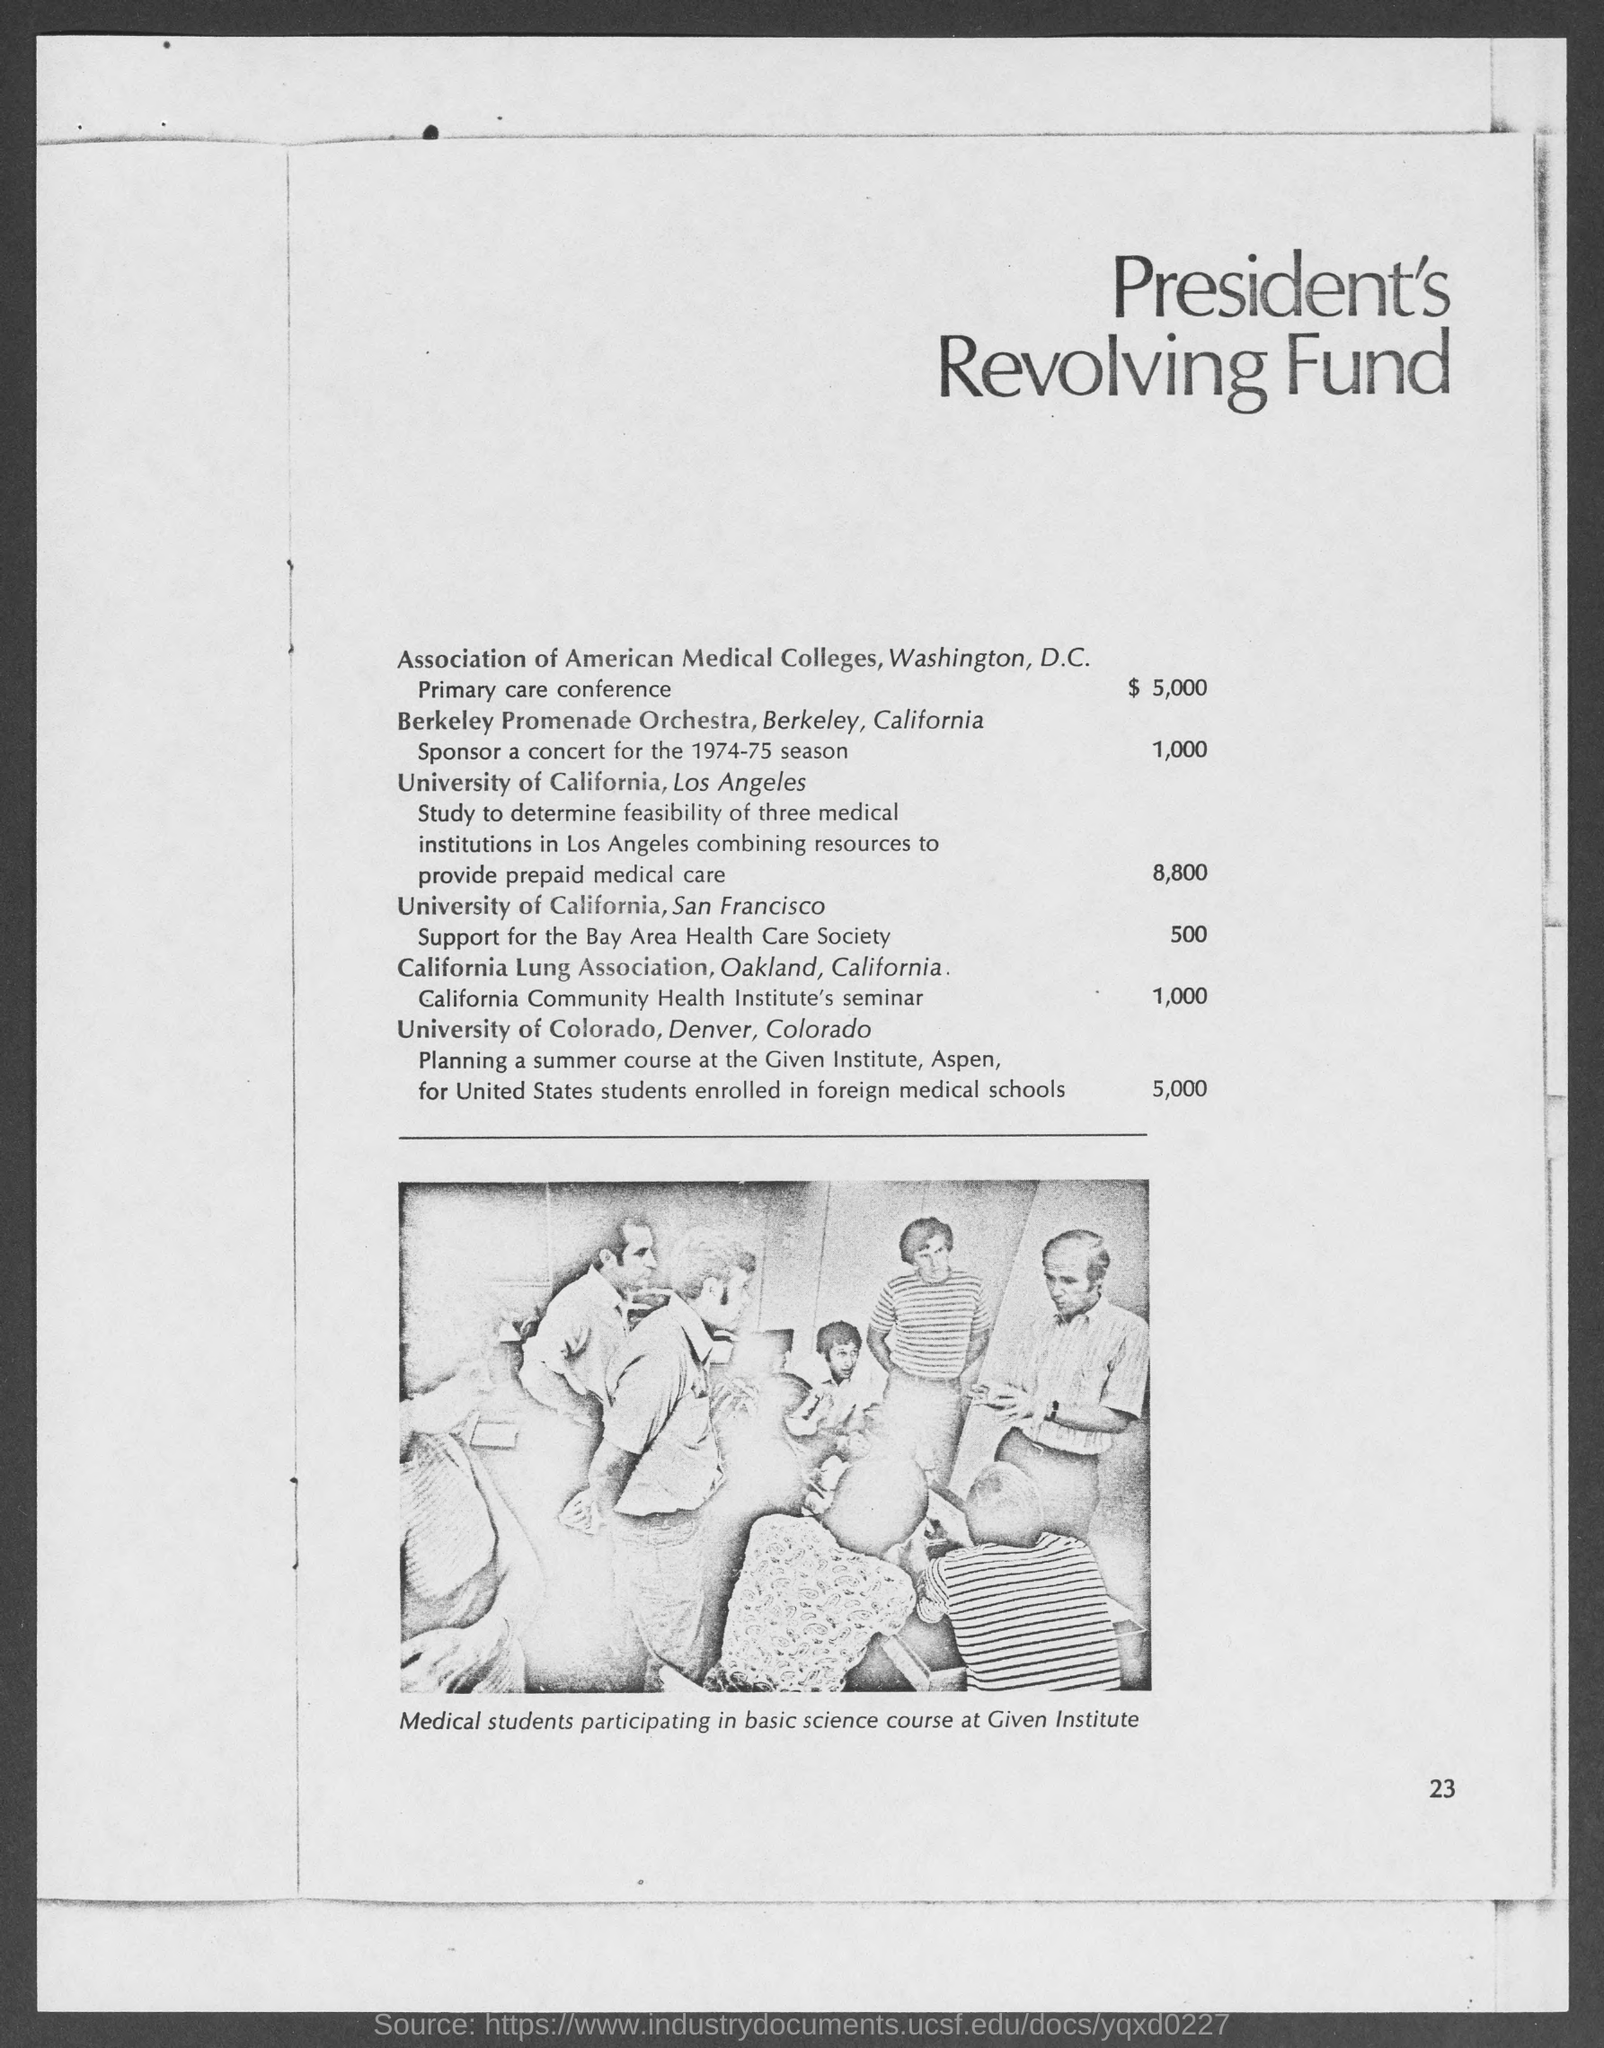Mention a couple of crucial points in this snapshot. The President's Revolving Fund for the Association of American Medical Colleges, located in Washington, D.C., was allocated $5,000 for the purpose of financing a primary care conference. The page number mentioned in this document is 23.. The image in the document shows medical students participating in a basic science course at Given Institute. 